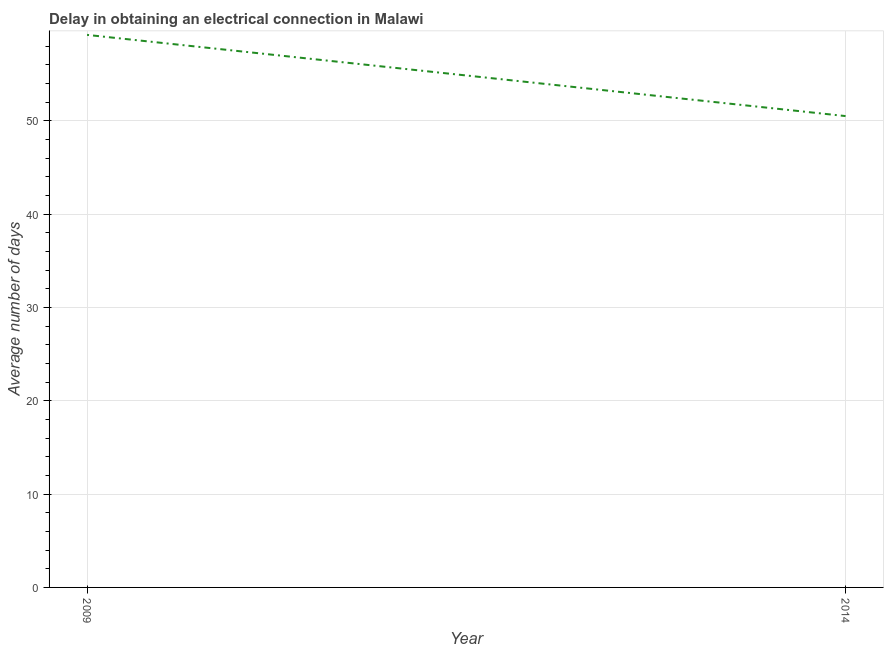What is the dalay in electrical connection in 2009?
Offer a very short reply. 59.2. Across all years, what is the maximum dalay in electrical connection?
Offer a very short reply. 59.2. Across all years, what is the minimum dalay in electrical connection?
Make the answer very short. 50.5. What is the sum of the dalay in electrical connection?
Give a very brief answer. 109.7. What is the difference between the dalay in electrical connection in 2009 and 2014?
Offer a terse response. 8.7. What is the average dalay in electrical connection per year?
Ensure brevity in your answer.  54.85. What is the median dalay in electrical connection?
Your response must be concise. 54.85. In how many years, is the dalay in electrical connection greater than 14 days?
Make the answer very short. 2. Do a majority of the years between 2009 and 2014 (inclusive) have dalay in electrical connection greater than 38 days?
Offer a terse response. Yes. What is the ratio of the dalay in electrical connection in 2009 to that in 2014?
Give a very brief answer. 1.17. Is the dalay in electrical connection in 2009 less than that in 2014?
Keep it short and to the point. No. In how many years, is the dalay in electrical connection greater than the average dalay in electrical connection taken over all years?
Give a very brief answer. 1. Does the dalay in electrical connection monotonically increase over the years?
Provide a short and direct response. No. What is the difference between two consecutive major ticks on the Y-axis?
Your response must be concise. 10. Are the values on the major ticks of Y-axis written in scientific E-notation?
Your response must be concise. No. Does the graph contain any zero values?
Ensure brevity in your answer.  No. Does the graph contain grids?
Offer a terse response. Yes. What is the title of the graph?
Make the answer very short. Delay in obtaining an electrical connection in Malawi. What is the label or title of the Y-axis?
Offer a terse response. Average number of days. What is the Average number of days of 2009?
Your answer should be very brief. 59.2. What is the Average number of days in 2014?
Offer a terse response. 50.5. What is the ratio of the Average number of days in 2009 to that in 2014?
Offer a very short reply. 1.17. 